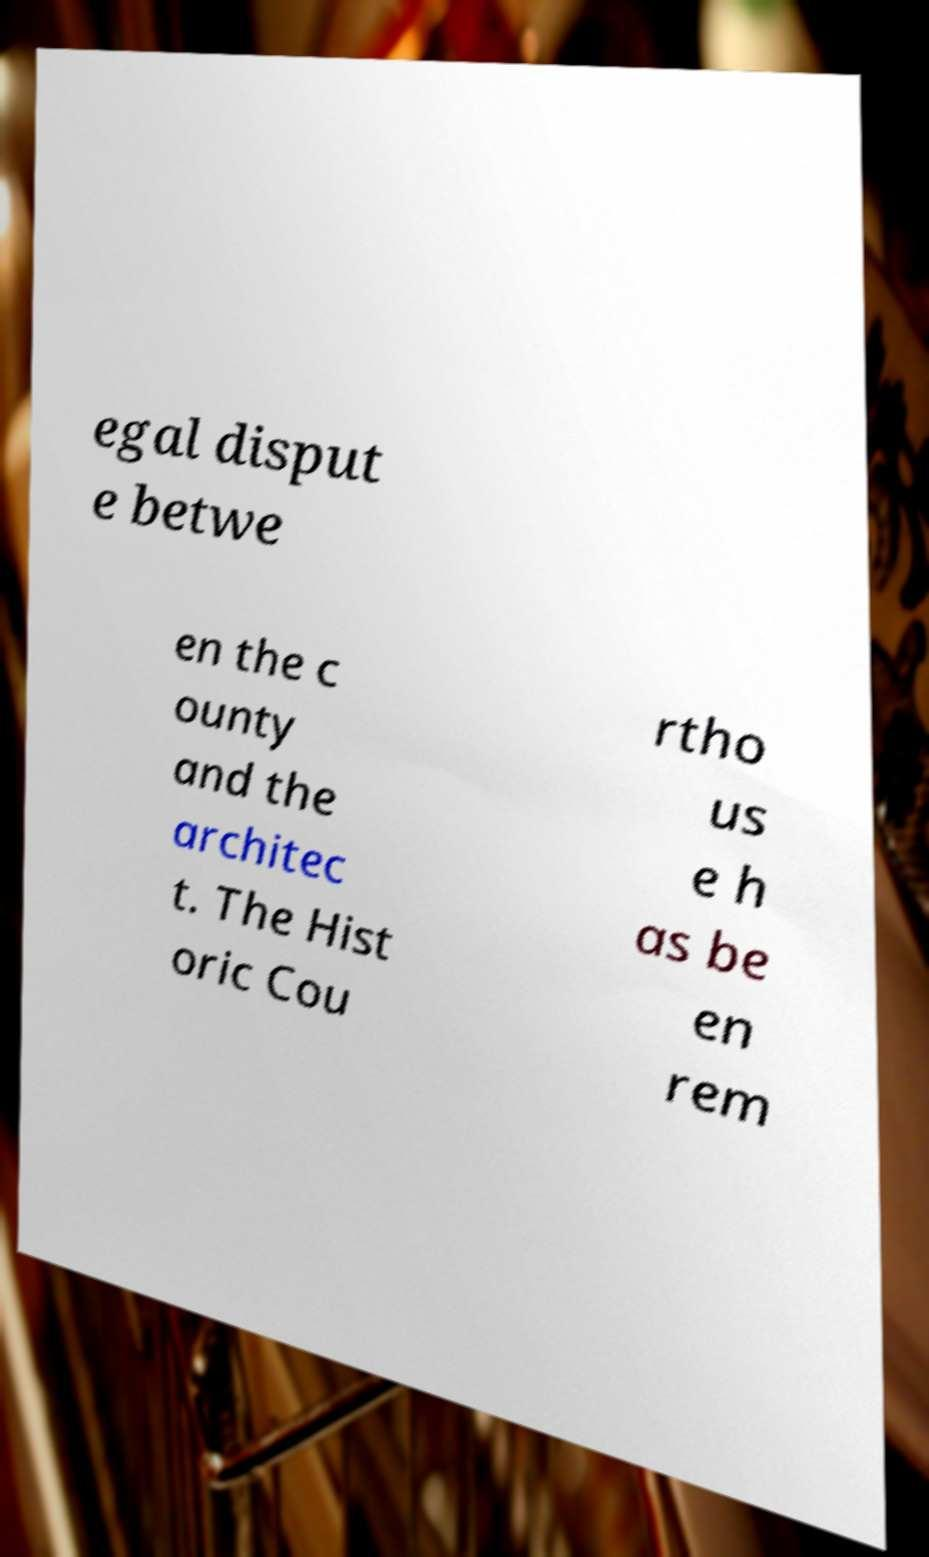Please identify and transcribe the text found in this image. egal disput e betwe en the c ounty and the architec t. The Hist oric Cou rtho us e h as be en rem 